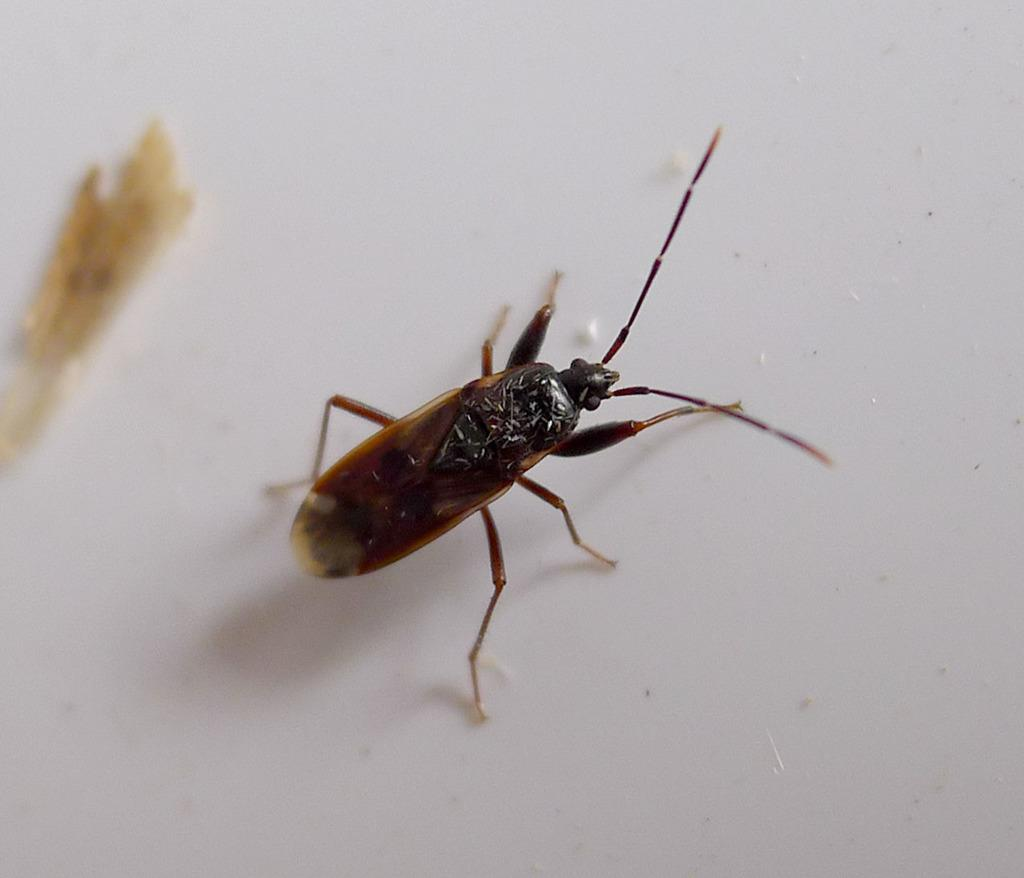What type of insect is present in the image? There is a cockroach in the image. How many eyes does the goat have in the image? There is no goat present in the image, only a cockroach. What is the texture of the cockroach's wings in the image? The provided facts do not mention the texture of the cockroach's wings, so we cannot answer this question definitively. 